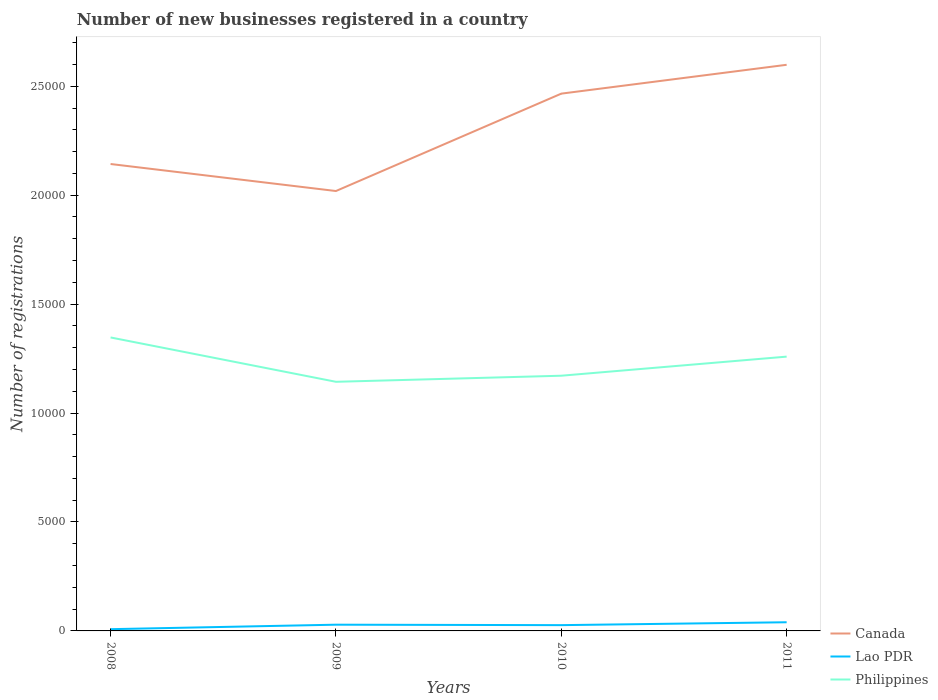Does the line corresponding to Philippines intersect with the line corresponding to Canada?
Your response must be concise. No. Across all years, what is the maximum number of new businesses registered in Philippines?
Provide a succinct answer. 1.14e+04. What is the total number of new businesses registered in Philippines in the graph?
Your response must be concise. -279. What is the difference between the highest and the second highest number of new businesses registered in Canada?
Provide a short and direct response. 5794. What is the difference between the highest and the lowest number of new businesses registered in Canada?
Keep it short and to the point. 2. How many lines are there?
Your response must be concise. 3. What is the difference between two consecutive major ticks on the Y-axis?
Offer a very short reply. 5000. Does the graph contain any zero values?
Keep it short and to the point. No. How many legend labels are there?
Provide a succinct answer. 3. What is the title of the graph?
Give a very brief answer. Number of new businesses registered in a country. Does "Iran" appear as one of the legend labels in the graph?
Offer a very short reply. No. What is the label or title of the X-axis?
Offer a very short reply. Years. What is the label or title of the Y-axis?
Give a very brief answer. Number of registrations. What is the Number of registrations of Canada in 2008?
Keep it short and to the point. 2.14e+04. What is the Number of registrations in Philippines in 2008?
Make the answer very short. 1.35e+04. What is the Number of registrations of Canada in 2009?
Offer a very short reply. 2.02e+04. What is the Number of registrations in Lao PDR in 2009?
Your answer should be very brief. 286. What is the Number of registrations of Philippines in 2009?
Keep it short and to the point. 1.14e+04. What is the Number of registrations of Canada in 2010?
Your answer should be compact. 2.47e+04. What is the Number of registrations of Lao PDR in 2010?
Make the answer very short. 265. What is the Number of registrations of Philippines in 2010?
Keep it short and to the point. 1.17e+04. What is the Number of registrations of Canada in 2011?
Keep it short and to the point. 2.60e+04. What is the Number of registrations in Lao PDR in 2011?
Give a very brief answer. 398. What is the Number of registrations in Philippines in 2011?
Provide a succinct answer. 1.26e+04. Across all years, what is the maximum Number of registrations of Canada?
Offer a very short reply. 2.60e+04. Across all years, what is the maximum Number of registrations in Lao PDR?
Keep it short and to the point. 398. Across all years, what is the maximum Number of registrations in Philippines?
Provide a succinct answer. 1.35e+04. Across all years, what is the minimum Number of registrations of Canada?
Offer a very short reply. 2.02e+04. Across all years, what is the minimum Number of registrations in Lao PDR?
Offer a very short reply. 80. Across all years, what is the minimum Number of registrations of Philippines?
Give a very brief answer. 1.14e+04. What is the total Number of registrations of Canada in the graph?
Your answer should be compact. 9.23e+04. What is the total Number of registrations in Lao PDR in the graph?
Ensure brevity in your answer.  1029. What is the total Number of registrations in Philippines in the graph?
Ensure brevity in your answer.  4.92e+04. What is the difference between the Number of registrations in Canada in 2008 and that in 2009?
Make the answer very short. 1240. What is the difference between the Number of registrations in Lao PDR in 2008 and that in 2009?
Your answer should be compact. -206. What is the difference between the Number of registrations in Philippines in 2008 and that in 2009?
Your response must be concise. 2035. What is the difference between the Number of registrations of Canada in 2008 and that in 2010?
Provide a succinct answer. -3230. What is the difference between the Number of registrations in Lao PDR in 2008 and that in 2010?
Your answer should be very brief. -185. What is the difference between the Number of registrations of Philippines in 2008 and that in 2010?
Offer a terse response. 1756. What is the difference between the Number of registrations in Canada in 2008 and that in 2011?
Offer a terse response. -4554. What is the difference between the Number of registrations in Lao PDR in 2008 and that in 2011?
Your response must be concise. -318. What is the difference between the Number of registrations in Philippines in 2008 and that in 2011?
Your answer should be very brief. 880. What is the difference between the Number of registrations in Canada in 2009 and that in 2010?
Make the answer very short. -4470. What is the difference between the Number of registrations of Philippines in 2009 and that in 2010?
Your response must be concise. -279. What is the difference between the Number of registrations in Canada in 2009 and that in 2011?
Your answer should be very brief. -5794. What is the difference between the Number of registrations in Lao PDR in 2009 and that in 2011?
Provide a short and direct response. -112. What is the difference between the Number of registrations in Philippines in 2009 and that in 2011?
Provide a short and direct response. -1155. What is the difference between the Number of registrations of Canada in 2010 and that in 2011?
Offer a terse response. -1324. What is the difference between the Number of registrations in Lao PDR in 2010 and that in 2011?
Provide a succinct answer. -133. What is the difference between the Number of registrations in Philippines in 2010 and that in 2011?
Make the answer very short. -876. What is the difference between the Number of registrations of Canada in 2008 and the Number of registrations of Lao PDR in 2009?
Offer a very short reply. 2.11e+04. What is the difference between the Number of registrations in Canada in 2008 and the Number of registrations in Philippines in 2009?
Offer a terse response. 9996. What is the difference between the Number of registrations of Lao PDR in 2008 and the Number of registrations of Philippines in 2009?
Your answer should be compact. -1.14e+04. What is the difference between the Number of registrations of Canada in 2008 and the Number of registrations of Lao PDR in 2010?
Ensure brevity in your answer.  2.12e+04. What is the difference between the Number of registrations in Canada in 2008 and the Number of registrations in Philippines in 2010?
Ensure brevity in your answer.  9717. What is the difference between the Number of registrations of Lao PDR in 2008 and the Number of registrations of Philippines in 2010?
Your answer should be compact. -1.16e+04. What is the difference between the Number of registrations of Canada in 2008 and the Number of registrations of Lao PDR in 2011?
Give a very brief answer. 2.10e+04. What is the difference between the Number of registrations in Canada in 2008 and the Number of registrations in Philippines in 2011?
Your answer should be very brief. 8841. What is the difference between the Number of registrations in Lao PDR in 2008 and the Number of registrations in Philippines in 2011?
Make the answer very short. -1.25e+04. What is the difference between the Number of registrations in Canada in 2009 and the Number of registrations in Lao PDR in 2010?
Your response must be concise. 1.99e+04. What is the difference between the Number of registrations in Canada in 2009 and the Number of registrations in Philippines in 2010?
Provide a short and direct response. 8477. What is the difference between the Number of registrations of Lao PDR in 2009 and the Number of registrations of Philippines in 2010?
Keep it short and to the point. -1.14e+04. What is the difference between the Number of registrations in Canada in 2009 and the Number of registrations in Lao PDR in 2011?
Ensure brevity in your answer.  1.98e+04. What is the difference between the Number of registrations in Canada in 2009 and the Number of registrations in Philippines in 2011?
Provide a succinct answer. 7601. What is the difference between the Number of registrations in Lao PDR in 2009 and the Number of registrations in Philippines in 2011?
Provide a short and direct response. -1.23e+04. What is the difference between the Number of registrations in Canada in 2010 and the Number of registrations in Lao PDR in 2011?
Make the answer very short. 2.43e+04. What is the difference between the Number of registrations in Canada in 2010 and the Number of registrations in Philippines in 2011?
Offer a very short reply. 1.21e+04. What is the difference between the Number of registrations in Lao PDR in 2010 and the Number of registrations in Philippines in 2011?
Keep it short and to the point. -1.23e+04. What is the average Number of registrations in Canada per year?
Make the answer very short. 2.31e+04. What is the average Number of registrations in Lao PDR per year?
Your answer should be compact. 257.25. What is the average Number of registrations in Philippines per year?
Offer a very short reply. 1.23e+04. In the year 2008, what is the difference between the Number of registrations in Canada and Number of registrations in Lao PDR?
Your response must be concise. 2.14e+04. In the year 2008, what is the difference between the Number of registrations in Canada and Number of registrations in Philippines?
Your response must be concise. 7961. In the year 2008, what is the difference between the Number of registrations in Lao PDR and Number of registrations in Philippines?
Offer a terse response. -1.34e+04. In the year 2009, what is the difference between the Number of registrations in Canada and Number of registrations in Lao PDR?
Your answer should be very brief. 1.99e+04. In the year 2009, what is the difference between the Number of registrations in Canada and Number of registrations in Philippines?
Offer a very short reply. 8756. In the year 2009, what is the difference between the Number of registrations in Lao PDR and Number of registrations in Philippines?
Ensure brevity in your answer.  -1.11e+04. In the year 2010, what is the difference between the Number of registrations in Canada and Number of registrations in Lao PDR?
Give a very brief answer. 2.44e+04. In the year 2010, what is the difference between the Number of registrations of Canada and Number of registrations of Philippines?
Your answer should be very brief. 1.29e+04. In the year 2010, what is the difference between the Number of registrations in Lao PDR and Number of registrations in Philippines?
Offer a terse response. -1.14e+04. In the year 2011, what is the difference between the Number of registrations of Canada and Number of registrations of Lao PDR?
Your answer should be compact. 2.56e+04. In the year 2011, what is the difference between the Number of registrations in Canada and Number of registrations in Philippines?
Ensure brevity in your answer.  1.34e+04. In the year 2011, what is the difference between the Number of registrations in Lao PDR and Number of registrations in Philippines?
Ensure brevity in your answer.  -1.22e+04. What is the ratio of the Number of registrations of Canada in 2008 to that in 2009?
Make the answer very short. 1.06. What is the ratio of the Number of registrations of Lao PDR in 2008 to that in 2009?
Make the answer very short. 0.28. What is the ratio of the Number of registrations of Philippines in 2008 to that in 2009?
Keep it short and to the point. 1.18. What is the ratio of the Number of registrations of Canada in 2008 to that in 2010?
Give a very brief answer. 0.87. What is the ratio of the Number of registrations of Lao PDR in 2008 to that in 2010?
Provide a succinct answer. 0.3. What is the ratio of the Number of registrations in Philippines in 2008 to that in 2010?
Provide a short and direct response. 1.15. What is the ratio of the Number of registrations in Canada in 2008 to that in 2011?
Provide a succinct answer. 0.82. What is the ratio of the Number of registrations of Lao PDR in 2008 to that in 2011?
Offer a very short reply. 0.2. What is the ratio of the Number of registrations in Philippines in 2008 to that in 2011?
Make the answer very short. 1.07. What is the ratio of the Number of registrations in Canada in 2009 to that in 2010?
Give a very brief answer. 0.82. What is the ratio of the Number of registrations of Lao PDR in 2009 to that in 2010?
Ensure brevity in your answer.  1.08. What is the ratio of the Number of registrations in Philippines in 2009 to that in 2010?
Your response must be concise. 0.98. What is the ratio of the Number of registrations in Canada in 2009 to that in 2011?
Offer a terse response. 0.78. What is the ratio of the Number of registrations of Lao PDR in 2009 to that in 2011?
Your answer should be compact. 0.72. What is the ratio of the Number of registrations in Philippines in 2009 to that in 2011?
Give a very brief answer. 0.91. What is the ratio of the Number of registrations of Canada in 2010 to that in 2011?
Provide a succinct answer. 0.95. What is the ratio of the Number of registrations in Lao PDR in 2010 to that in 2011?
Make the answer very short. 0.67. What is the ratio of the Number of registrations of Philippines in 2010 to that in 2011?
Make the answer very short. 0.93. What is the difference between the highest and the second highest Number of registrations in Canada?
Your response must be concise. 1324. What is the difference between the highest and the second highest Number of registrations of Lao PDR?
Ensure brevity in your answer.  112. What is the difference between the highest and the second highest Number of registrations in Philippines?
Provide a short and direct response. 880. What is the difference between the highest and the lowest Number of registrations of Canada?
Ensure brevity in your answer.  5794. What is the difference between the highest and the lowest Number of registrations of Lao PDR?
Keep it short and to the point. 318. What is the difference between the highest and the lowest Number of registrations of Philippines?
Keep it short and to the point. 2035. 